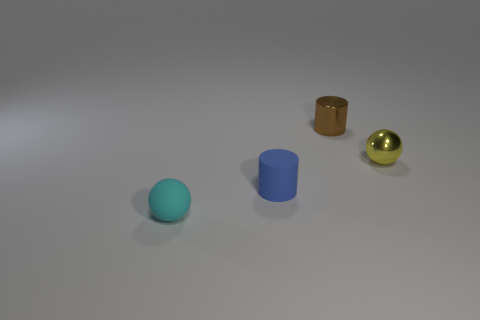Add 2 tiny metallic cylinders. How many objects exist? 6 Subtract 0 purple spheres. How many objects are left? 4 Subtract all yellow metallic objects. Subtract all yellow shiny things. How many objects are left? 2 Add 1 tiny brown cylinders. How many tiny brown cylinders are left? 2 Add 2 yellow cylinders. How many yellow cylinders exist? 2 